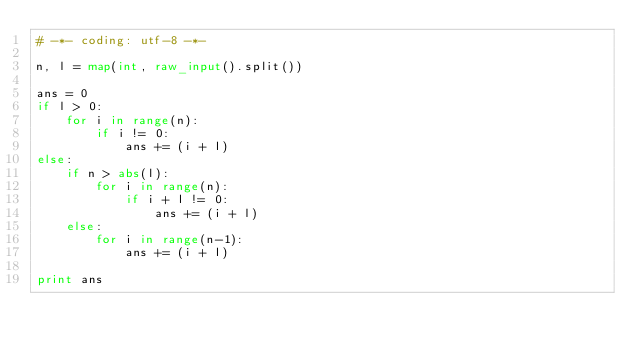<code> <loc_0><loc_0><loc_500><loc_500><_Python_># -*- coding: utf-8 -*-

n, l = map(int, raw_input().split())

ans = 0
if l > 0:
    for i in range(n):
        if i != 0:
            ans += (i + l)
else:
    if n > abs(l):
        for i in range(n):
            if i + l != 0:
                ans += (i + l)
    else:
        for i in range(n-1):
            ans += (i + l)

print ans
        
</code> 